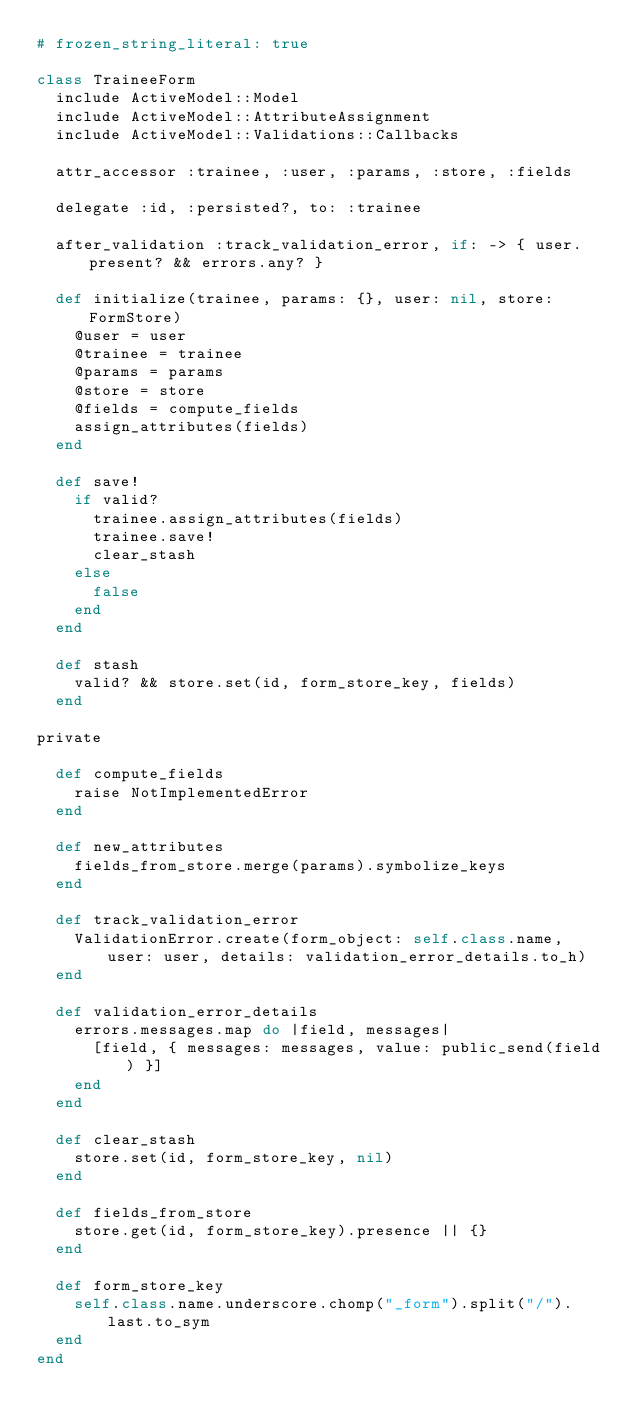Convert code to text. <code><loc_0><loc_0><loc_500><loc_500><_Ruby_># frozen_string_literal: true

class TraineeForm
  include ActiveModel::Model
  include ActiveModel::AttributeAssignment
  include ActiveModel::Validations::Callbacks

  attr_accessor :trainee, :user, :params, :store, :fields

  delegate :id, :persisted?, to: :trainee

  after_validation :track_validation_error, if: -> { user.present? && errors.any? }

  def initialize(trainee, params: {}, user: nil, store: FormStore)
    @user = user
    @trainee = trainee
    @params = params
    @store = store
    @fields = compute_fields
    assign_attributes(fields)
  end

  def save!
    if valid?
      trainee.assign_attributes(fields)
      trainee.save!
      clear_stash
    else
      false
    end
  end

  def stash
    valid? && store.set(id, form_store_key, fields)
  end

private

  def compute_fields
    raise NotImplementedError
  end

  def new_attributes
    fields_from_store.merge(params).symbolize_keys
  end

  def track_validation_error
    ValidationError.create(form_object: self.class.name, user: user, details: validation_error_details.to_h)
  end

  def validation_error_details
    errors.messages.map do |field, messages|
      [field, { messages: messages, value: public_send(field) }]
    end
  end

  def clear_stash
    store.set(id, form_store_key, nil)
  end

  def fields_from_store
    store.get(id, form_store_key).presence || {}
  end

  def form_store_key
    self.class.name.underscore.chomp("_form").split("/").last.to_sym
  end
end
</code> 